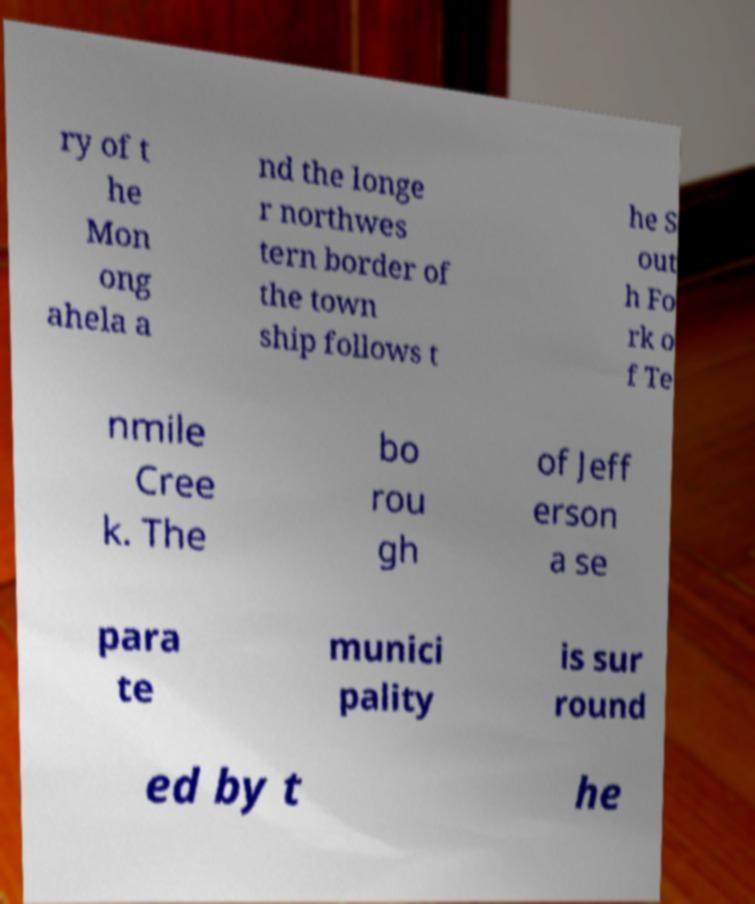Can you read and provide the text displayed in the image?This photo seems to have some interesting text. Can you extract and type it out for me? ry of t he Mon ong ahela a nd the longe r northwes tern border of the town ship follows t he S out h Fo rk o f Te nmile Cree k. The bo rou gh of Jeff erson a se para te munici pality is sur round ed by t he 